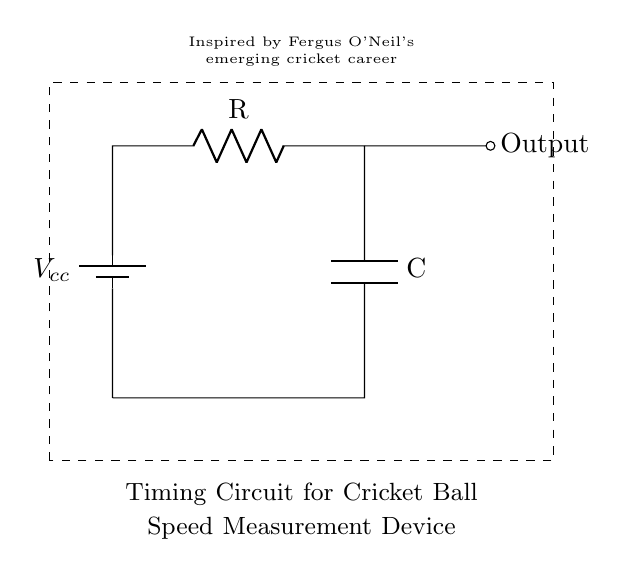What is the main function of this circuit? The main function is to measure the timing associated with the speed of a cricket ball, indicated by the output signal.
Answer: Speed measurement What components are present in this circuit? The components include a battery, a resistor, and a capacitor, as shown in the diagram.
Answer: Battery, resistor, capacitor What is the role of the capacitor in this circuit? The capacitor stores charge and helps determine the timing characteristics of the circuit, influencing the timing for speed measurement.
Answer: Timing What type of circuit is this? The circuit shown is a Resistor-Capacitor (RC) timing circuit, which is typically used for generating delays or timing intervals.
Answer: RC timing circuit What does the dashed rectangle represent? The dashed rectangle indicates the boundary of the circuit, often used to differentiate the circuit from other schematic elements or annotations outside of the circuit.
Answer: Circuit boundary What happens to the output when the voltage is applied? When voltage is applied, the capacitor charges through the resistor, which affects the timing and eventually produces a signal at the output.
Answer: Produces output signal How can this circuit be used in cricket coaching? This circuit can be utilized to analyze the speed of cricket balls, aiding coaches in assessing player performance and identifying areas for improvement.
Answer: Speed analysis for coaching 